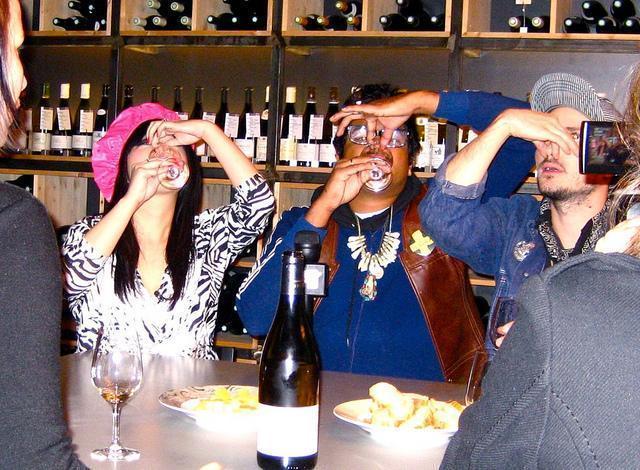How many wine glasses are visible?
Give a very brief answer. 1. How many bowls are in the picture?
Give a very brief answer. 2. How many people can you see?
Give a very brief answer. 5. 